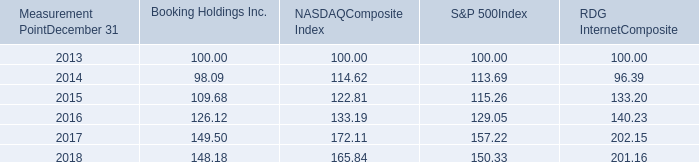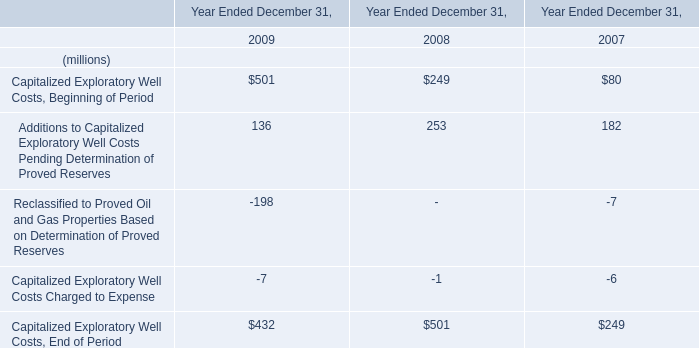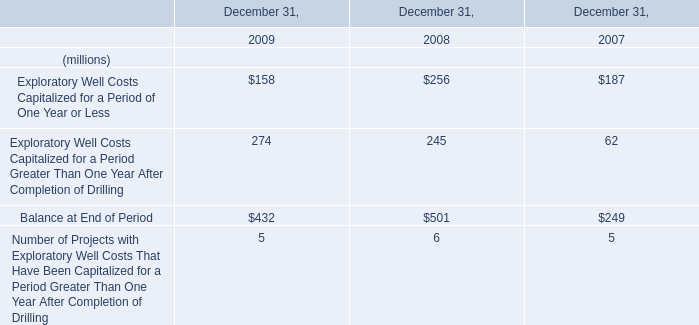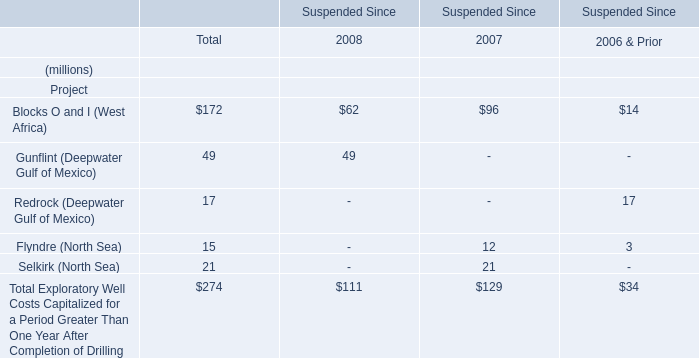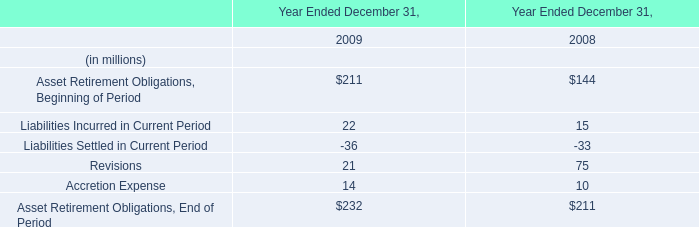In the year with largest Capitalized Exploratory Well Costs Charged to Expense, what's the increasing rate of Capitalized Exploratory Well Costs, End of Period? 
Computations: ((501 - 249) / 249)
Answer: 1.01205. 